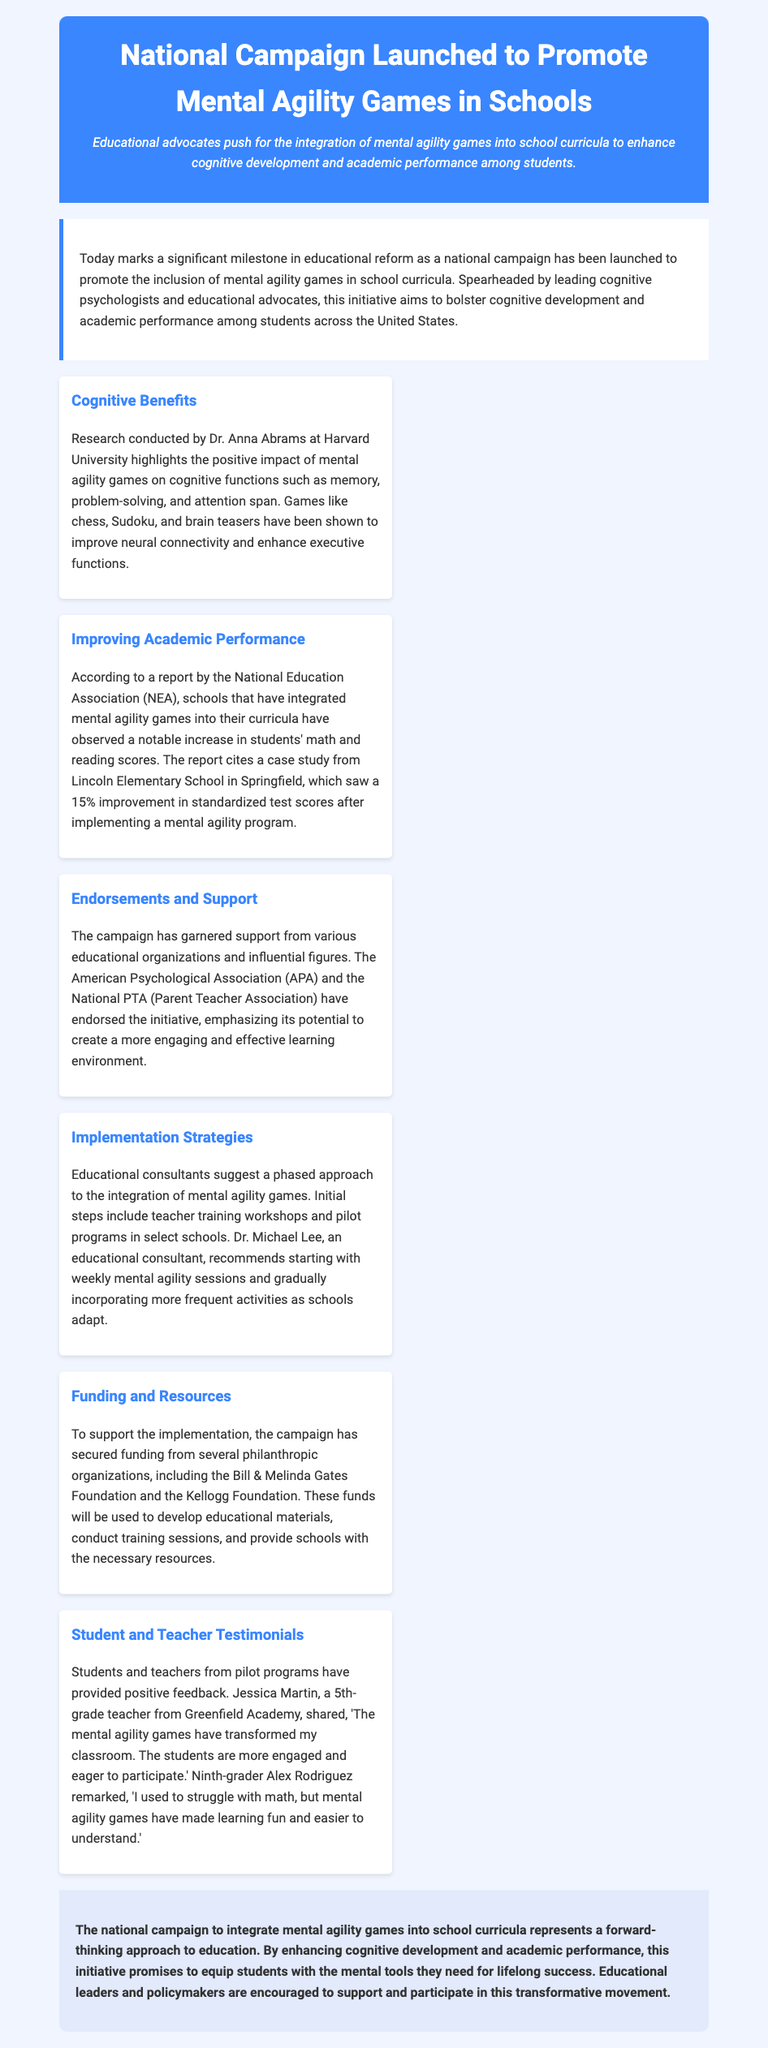What is the focus of the national campaign? The national campaign focuses on promoting the inclusion of mental agility games in school curricula.
Answer: Mental agility games Who conducted research on cognitive benefits? Dr. Anna Abrams conducted research highlighting the impact of mental agility games.
Answer: Dr. Anna Abrams What was the percentage improvement in standardized test scores at Lincoln Elementary School? The case study from Lincoln Elementary School reported a 15% improvement in standardized test scores.
Answer: 15% Which organizations endorsed the initiative? The campaign has garnered support from the American Psychological Association and the National PTA.
Answer: American Psychological Association, National PTA What do educational consultants recommend for implementation? Educational consultants suggest a phased approach, starting with teacher training workshops and pilot programs.
Answer: Phased approach How has funding for the campaign been secured? The campaign has secured funding from philanthropic organizations like the Bill & Melinda Gates Foundation.
Answer: Bill & Melinda Gates Foundation What positive feedback did a 5th-grade teacher provide? Jessica Martin mentioned that the mental agility games transformed her classroom, making students more engaged.
Answer: Transformed my classroom What is the aim of integrating mental agility games in education? The aim is to enhance cognitive development and academic performance among students.
Answer: Enhance cognitive development and academic performance 